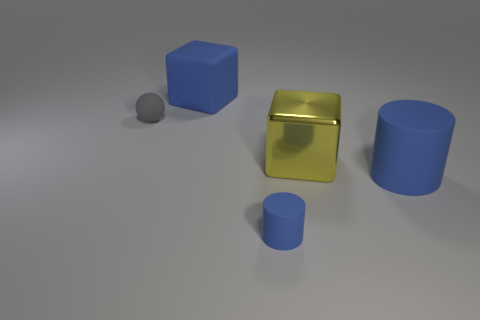What number of rubber things are on the right side of the gray rubber ball and on the left side of the big yellow metallic object?
Offer a terse response. 2. What color is the matte cube?
Offer a very short reply. Blue. There is a large blue thing that is the same shape as the big yellow thing; what is it made of?
Provide a short and direct response. Rubber. Is there anything else that is the same material as the gray object?
Your answer should be very brief. Yes. Is the color of the tiny rubber ball the same as the large rubber cube?
Your response must be concise. No. What is the shape of the large thing left of the tiny object to the right of the small ball?
Make the answer very short. Cube. There is a gray thing that is made of the same material as the tiny blue object; what is its shape?
Keep it short and to the point. Sphere. How many other objects are there of the same shape as the tiny gray matte thing?
Your response must be concise. 0. There is a rubber thing that is to the left of the rubber cube; is its size the same as the tiny blue rubber cylinder?
Make the answer very short. Yes. Is the number of gray balls that are to the right of the big cylinder greater than the number of yellow metal cubes?
Your answer should be very brief. No. 